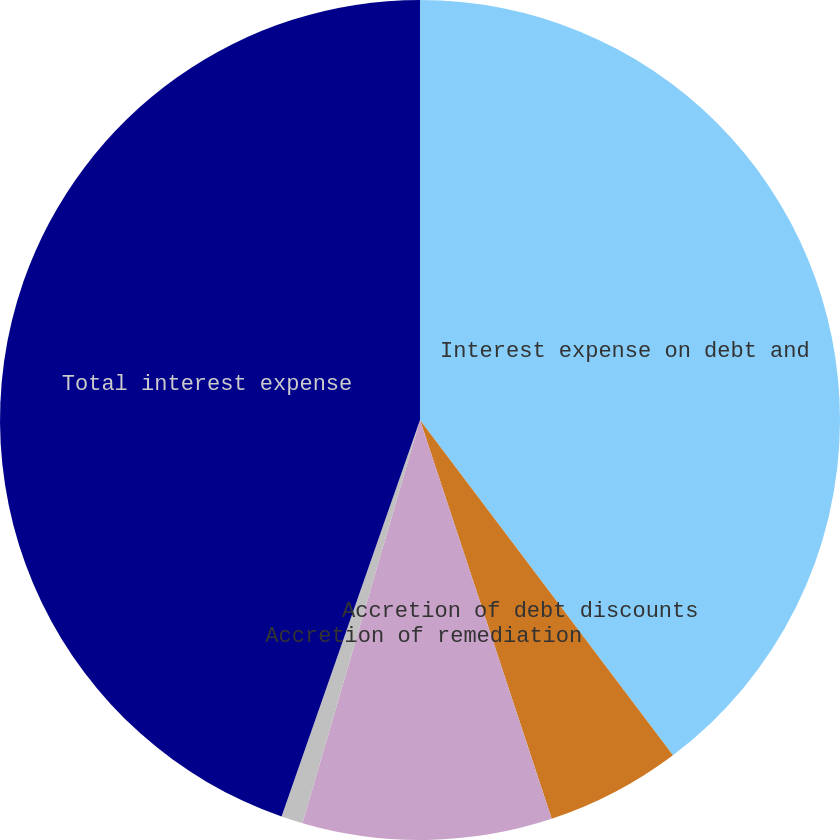Convert chart to OTSL. <chart><loc_0><loc_0><loc_500><loc_500><pie_chart><fcel>Interest expense on debt and<fcel>Accretion of debt discounts<fcel>Accretion of remediation<fcel>Less capitalized interest<fcel>Total interest expense<nl><fcel>39.71%<fcel>5.21%<fcel>9.59%<fcel>0.83%<fcel>44.65%<nl></chart> 